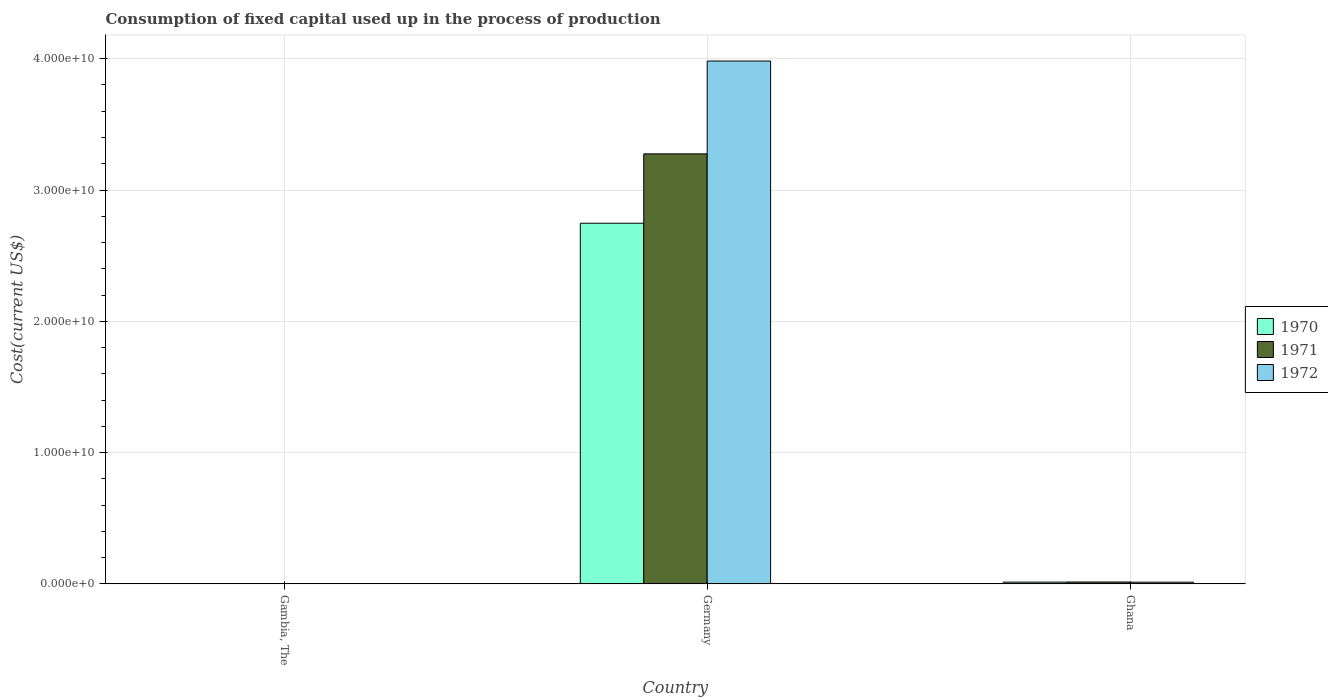How many different coloured bars are there?
Offer a very short reply. 3. Are the number of bars per tick equal to the number of legend labels?
Your answer should be very brief. Yes. How many bars are there on the 2nd tick from the left?
Your response must be concise. 3. How many bars are there on the 1st tick from the right?
Your response must be concise. 3. What is the label of the 3rd group of bars from the left?
Your response must be concise. Ghana. In how many cases, is the number of bars for a given country not equal to the number of legend labels?
Your answer should be very brief. 0. What is the amount consumed in the process of production in 1971 in Ghana?
Provide a succinct answer. 1.40e+08. Across all countries, what is the maximum amount consumed in the process of production in 1971?
Give a very brief answer. 3.28e+1. Across all countries, what is the minimum amount consumed in the process of production in 1971?
Keep it short and to the point. 4.78e+06. In which country was the amount consumed in the process of production in 1970 minimum?
Keep it short and to the point. Gambia, The. What is the total amount consumed in the process of production in 1970 in the graph?
Keep it short and to the point. 2.76e+1. What is the difference between the amount consumed in the process of production in 1971 in Gambia, The and that in Ghana?
Provide a succinct answer. -1.36e+08. What is the difference between the amount consumed in the process of production in 1972 in Germany and the amount consumed in the process of production in 1971 in Gambia, The?
Make the answer very short. 3.98e+1. What is the average amount consumed in the process of production in 1972 per country?
Make the answer very short. 1.33e+1. What is the difference between the amount consumed in the process of production of/in 1970 and amount consumed in the process of production of/in 1971 in Ghana?
Your answer should be compact. -8.65e+06. In how many countries, is the amount consumed in the process of production in 1972 greater than 12000000000 US$?
Provide a short and direct response. 1. What is the ratio of the amount consumed in the process of production in 1972 in Gambia, The to that in Germany?
Provide a short and direct response. 0. Is the difference between the amount consumed in the process of production in 1970 in Gambia, The and Ghana greater than the difference between the amount consumed in the process of production in 1971 in Gambia, The and Ghana?
Your response must be concise. Yes. What is the difference between the highest and the second highest amount consumed in the process of production in 1971?
Provide a short and direct response. 1.36e+08. What is the difference between the highest and the lowest amount consumed in the process of production in 1972?
Keep it short and to the point. 3.98e+1. Is it the case that in every country, the sum of the amount consumed in the process of production in 1970 and amount consumed in the process of production in 1972 is greater than the amount consumed in the process of production in 1971?
Your response must be concise. Yes. What is the difference between two consecutive major ticks on the Y-axis?
Keep it short and to the point. 1.00e+1. Does the graph contain any zero values?
Make the answer very short. No. Does the graph contain grids?
Your answer should be compact. Yes. How many legend labels are there?
Your response must be concise. 3. How are the legend labels stacked?
Provide a succinct answer. Vertical. What is the title of the graph?
Make the answer very short. Consumption of fixed capital used up in the process of production. What is the label or title of the X-axis?
Provide a short and direct response. Country. What is the label or title of the Y-axis?
Provide a succinct answer. Cost(current US$). What is the Cost(current US$) of 1970 in Gambia, The?
Offer a very short reply. 4.37e+06. What is the Cost(current US$) of 1971 in Gambia, The?
Offer a terse response. 4.78e+06. What is the Cost(current US$) in 1972 in Gambia, The?
Your answer should be compact. 5.52e+06. What is the Cost(current US$) in 1970 in Germany?
Provide a short and direct response. 2.75e+1. What is the Cost(current US$) in 1971 in Germany?
Ensure brevity in your answer.  3.28e+1. What is the Cost(current US$) of 1972 in Germany?
Provide a succinct answer. 3.98e+1. What is the Cost(current US$) in 1970 in Ghana?
Your answer should be compact. 1.32e+08. What is the Cost(current US$) of 1971 in Ghana?
Give a very brief answer. 1.40e+08. What is the Cost(current US$) in 1972 in Ghana?
Offer a very short reply. 1.28e+08. Across all countries, what is the maximum Cost(current US$) in 1970?
Offer a very short reply. 2.75e+1. Across all countries, what is the maximum Cost(current US$) of 1971?
Offer a terse response. 3.28e+1. Across all countries, what is the maximum Cost(current US$) in 1972?
Offer a very short reply. 3.98e+1. Across all countries, what is the minimum Cost(current US$) in 1970?
Offer a terse response. 4.37e+06. Across all countries, what is the minimum Cost(current US$) in 1971?
Provide a short and direct response. 4.78e+06. Across all countries, what is the minimum Cost(current US$) in 1972?
Your answer should be compact. 5.52e+06. What is the total Cost(current US$) in 1970 in the graph?
Your answer should be very brief. 2.76e+1. What is the total Cost(current US$) in 1971 in the graph?
Ensure brevity in your answer.  3.29e+1. What is the total Cost(current US$) of 1972 in the graph?
Give a very brief answer. 4.00e+1. What is the difference between the Cost(current US$) of 1970 in Gambia, The and that in Germany?
Your response must be concise. -2.75e+1. What is the difference between the Cost(current US$) of 1971 in Gambia, The and that in Germany?
Provide a short and direct response. -3.27e+1. What is the difference between the Cost(current US$) in 1972 in Gambia, The and that in Germany?
Offer a terse response. -3.98e+1. What is the difference between the Cost(current US$) in 1970 in Gambia, The and that in Ghana?
Offer a very short reply. -1.27e+08. What is the difference between the Cost(current US$) in 1971 in Gambia, The and that in Ghana?
Make the answer very short. -1.36e+08. What is the difference between the Cost(current US$) in 1972 in Gambia, The and that in Ghana?
Your answer should be compact. -1.23e+08. What is the difference between the Cost(current US$) of 1970 in Germany and that in Ghana?
Offer a very short reply. 2.73e+1. What is the difference between the Cost(current US$) in 1971 in Germany and that in Ghana?
Give a very brief answer. 3.26e+1. What is the difference between the Cost(current US$) of 1972 in Germany and that in Ghana?
Offer a terse response. 3.97e+1. What is the difference between the Cost(current US$) in 1970 in Gambia, The and the Cost(current US$) in 1971 in Germany?
Your answer should be compact. -3.27e+1. What is the difference between the Cost(current US$) in 1970 in Gambia, The and the Cost(current US$) in 1972 in Germany?
Offer a terse response. -3.98e+1. What is the difference between the Cost(current US$) in 1971 in Gambia, The and the Cost(current US$) in 1972 in Germany?
Ensure brevity in your answer.  -3.98e+1. What is the difference between the Cost(current US$) of 1970 in Gambia, The and the Cost(current US$) of 1971 in Ghana?
Provide a succinct answer. -1.36e+08. What is the difference between the Cost(current US$) in 1970 in Gambia, The and the Cost(current US$) in 1972 in Ghana?
Ensure brevity in your answer.  -1.24e+08. What is the difference between the Cost(current US$) in 1971 in Gambia, The and the Cost(current US$) in 1972 in Ghana?
Make the answer very short. -1.23e+08. What is the difference between the Cost(current US$) in 1970 in Germany and the Cost(current US$) in 1971 in Ghana?
Give a very brief answer. 2.73e+1. What is the difference between the Cost(current US$) of 1970 in Germany and the Cost(current US$) of 1972 in Ghana?
Give a very brief answer. 2.73e+1. What is the difference between the Cost(current US$) of 1971 in Germany and the Cost(current US$) of 1972 in Ghana?
Keep it short and to the point. 3.26e+1. What is the average Cost(current US$) in 1970 per country?
Provide a succinct answer. 9.20e+09. What is the average Cost(current US$) of 1971 per country?
Ensure brevity in your answer.  1.10e+1. What is the average Cost(current US$) in 1972 per country?
Keep it short and to the point. 1.33e+1. What is the difference between the Cost(current US$) in 1970 and Cost(current US$) in 1971 in Gambia, The?
Keep it short and to the point. -4.06e+05. What is the difference between the Cost(current US$) of 1970 and Cost(current US$) of 1972 in Gambia, The?
Keep it short and to the point. -1.15e+06. What is the difference between the Cost(current US$) of 1971 and Cost(current US$) of 1972 in Gambia, The?
Ensure brevity in your answer.  -7.48e+05. What is the difference between the Cost(current US$) in 1970 and Cost(current US$) in 1971 in Germany?
Offer a terse response. -5.28e+09. What is the difference between the Cost(current US$) of 1970 and Cost(current US$) of 1972 in Germany?
Ensure brevity in your answer.  -1.24e+1. What is the difference between the Cost(current US$) of 1971 and Cost(current US$) of 1972 in Germany?
Give a very brief answer. -7.07e+09. What is the difference between the Cost(current US$) of 1970 and Cost(current US$) of 1971 in Ghana?
Keep it short and to the point. -8.65e+06. What is the difference between the Cost(current US$) in 1970 and Cost(current US$) in 1972 in Ghana?
Give a very brief answer. 3.64e+06. What is the difference between the Cost(current US$) of 1971 and Cost(current US$) of 1972 in Ghana?
Your answer should be very brief. 1.23e+07. What is the ratio of the Cost(current US$) of 1970 in Gambia, The to that in Germany?
Your answer should be compact. 0. What is the ratio of the Cost(current US$) in 1971 in Gambia, The to that in Germany?
Ensure brevity in your answer.  0. What is the ratio of the Cost(current US$) of 1972 in Gambia, The to that in Germany?
Ensure brevity in your answer.  0. What is the ratio of the Cost(current US$) in 1970 in Gambia, The to that in Ghana?
Your answer should be compact. 0.03. What is the ratio of the Cost(current US$) in 1971 in Gambia, The to that in Ghana?
Offer a very short reply. 0.03. What is the ratio of the Cost(current US$) of 1972 in Gambia, The to that in Ghana?
Give a very brief answer. 0.04. What is the ratio of the Cost(current US$) in 1970 in Germany to that in Ghana?
Offer a very short reply. 208.57. What is the ratio of the Cost(current US$) in 1971 in Germany to that in Ghana?
Offer a terse response. 233.35. What is the ratio of the Cost(current US$) in 1972 in Germany to that in Ghana?
Ensure brevity in your answer.  310.97. What is the difference between the highest and the second highest Cost(current US$) in 1970?
Your answer should be very brief. 2.73e+1. What is the difference between the highest and the second highest Cost(current US$) in 1971?
Ensure brevity in your answer.  3.26e+1. What is the difference between the highest and the second highest Cost(current US$) of 1972?
Ensure brevity in your answer.  3.97e+1. What is the difference between the highest and the lowest Cost(current US$) in 1970?
Ensure brevity in your answer.  2.75e+1. What is the difference between the highest and the lowest Cost(current US$) in 1971?
Your answer should be compact. 3.27e+1. What is the difference between the highest and the lowest Cost(current US$) in 1972?
Provide a succinct answer. 3.98e+1. 